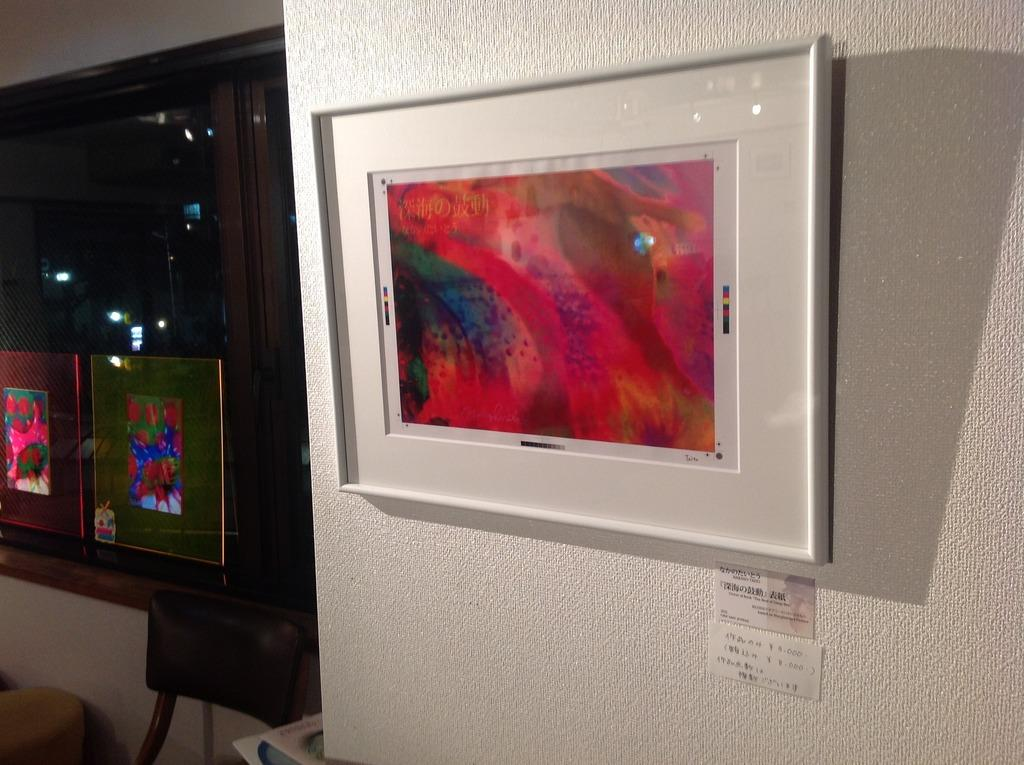What is attached to the wall in the image? There is a photo frame attached to the wall in the image. Are there any other photo frames in the image? Yes, there are other photo frames in the image. What piece of furniture can be seen in the image? There is a chair in the image. Where is the glass window located in the image? The glass window is in the left corner of the image. What type of cream can be seen on the chair in the image? There is no cream visible on the chair in the image. What subject is being taught in the image? There is no teaching or classroom setting depicted in the image. 